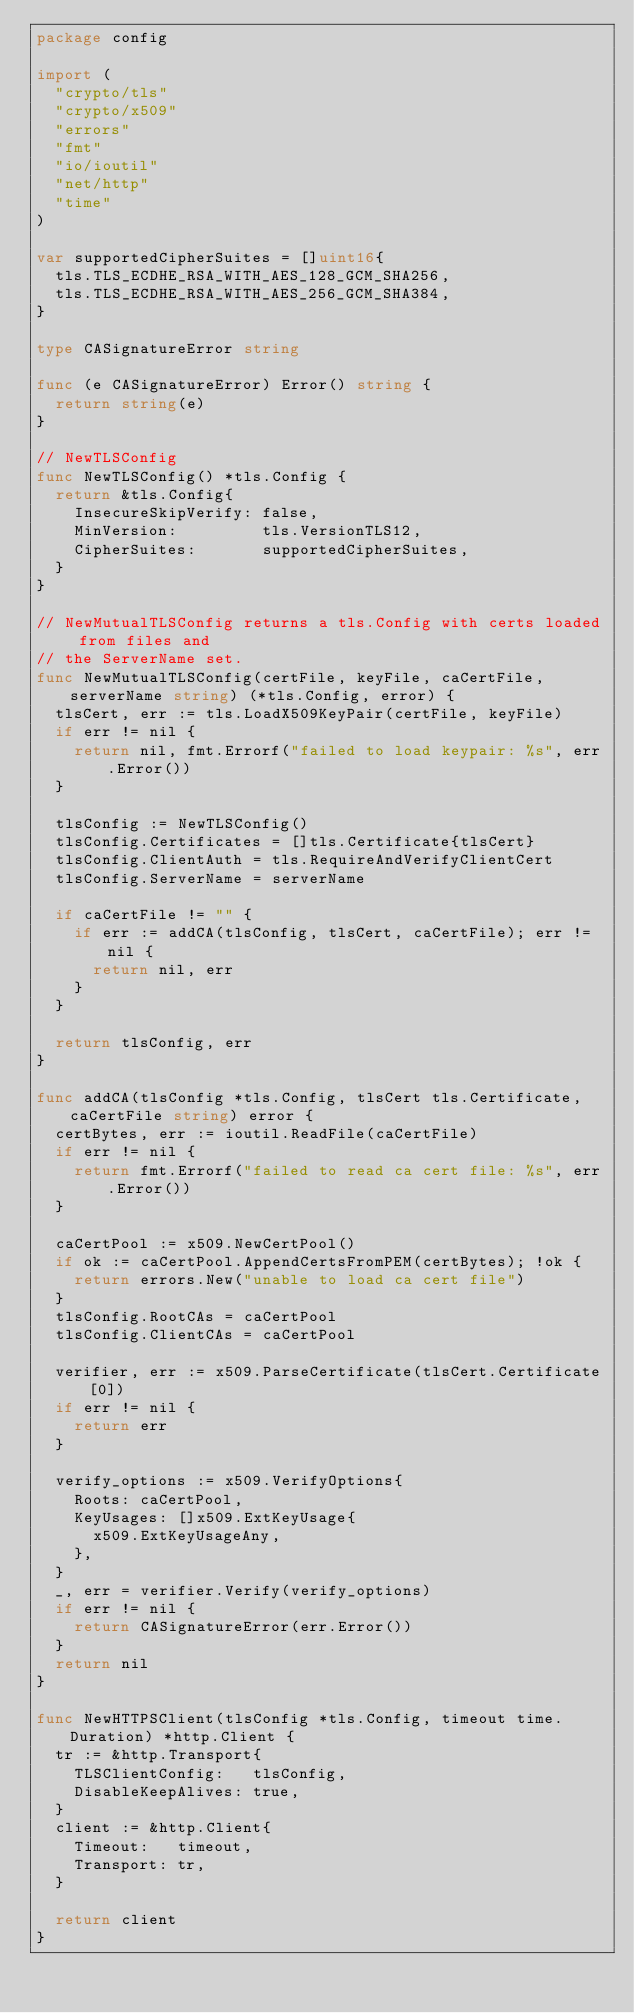Convert code to text. <code><loc_0><loc_0><loc_500><loc_500><_Go_>package config

import (
	"crypto/tls"
	"crypto/x509"
	"errors"
	"fmt"
	"io/ioutil"
	"net/http"
	"time"
)

var supportedCipherSuites = []uint16{
	tls.TLS_ECDHE_RSA_WITH_AES_128_GCM_SHA256,
	tls.TLS_ECDHE_RSA_WITH_AES_256_GCM_SHA384,
}

type CASignatureError string

func (e CASignatureError) Error() string {
	return string(e)
}

// NewTLSConfig
func NewTLSConfig() *tls.Config {
	return &tls.Config{
		InsecureSkipVerify: false,
		MinVersion:         tls.VersionTLS12,
		CipherSuites:       supportedCipherSuites,
	}
}

// NewMutualTLSConfig returns a tls.Config with certs loaded from files and
// the ServerName set.
func NewMutualTLSConfig(certFile, keyFile, caCertFile, serverName string) (*tls.Config, error) {
	tlsCert, err := tls.LoadX509KeyPair(certFile, keyFile)
	if err != nil {
		return nil, fmt.Errorf("failed to load keypair: %s", err.Error())
	}

	tlsConfig := NewTLSConfig()
	tlsConfig.Certificates = []tls.Certificate{tlsCert}
	tlsConfig.ClientAuth = tls.RequireAndVerifyClientCert
	tlsConfig.ServerName = serverName

	if caCertFile != "" {
		if err := addCA(tlsConfig, tlsCert, caCertFile); err != nil {
			return nil, err
		}
	}

	return tlsConfig, err
}

func addCA(tlsConfig *tls.Config, tlsCert tls.Certificate, caCertFile string) error {
	certBytes, err := ioutil.ReadFile(caCertFile)
	if err != nil {
		return fmt.Errorf("failed to read ca cert file: %s", err.Error())
	}

	caCertPool := x509.NewCertPool()
	if ok := caCertPool.AppendCertsFromPEM(certBytes); !ok {
		return errors.New("unable to load ca cert file")
	}
	tlsConfig.RootCAs = caCertPool
	tlsConfig.ClientCAs = caCertPool

	verifier, err := x509.ParseCertificate(tlsCert.Certificate[0])
	if err != nil {
		return err
	}

	verify_options := x509.VerifyOptions{
		Roots: caCertPool,
		KeyUsages: []x509.ExtKeyUsage{
			x509.ExtKeyUsageAny,
		},
	}
	_, err = verifier.Verify(verify_options)
	if err != nil {
		return CASignatureError(err.Error())
	}
	return nil
}

func NewHTTPSClient(tlsConfig *tls.Config, timeout time.Duration) *http.Client {
	tr := &http.Transport{
		TLSClientConfig:   tlsConfig,
		DisableKeepAlives: true,
	}
	client := &http.Client{
		Timeout:   timeout,
		Transport: tr,
	}

	return client
}
</code> 